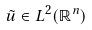<formula> <loc_0><loc_0><loc_500><loc_500>\tilde { u } \in L ^ { 2 } ( \mathbb { R } ^ { n } )</formula> 